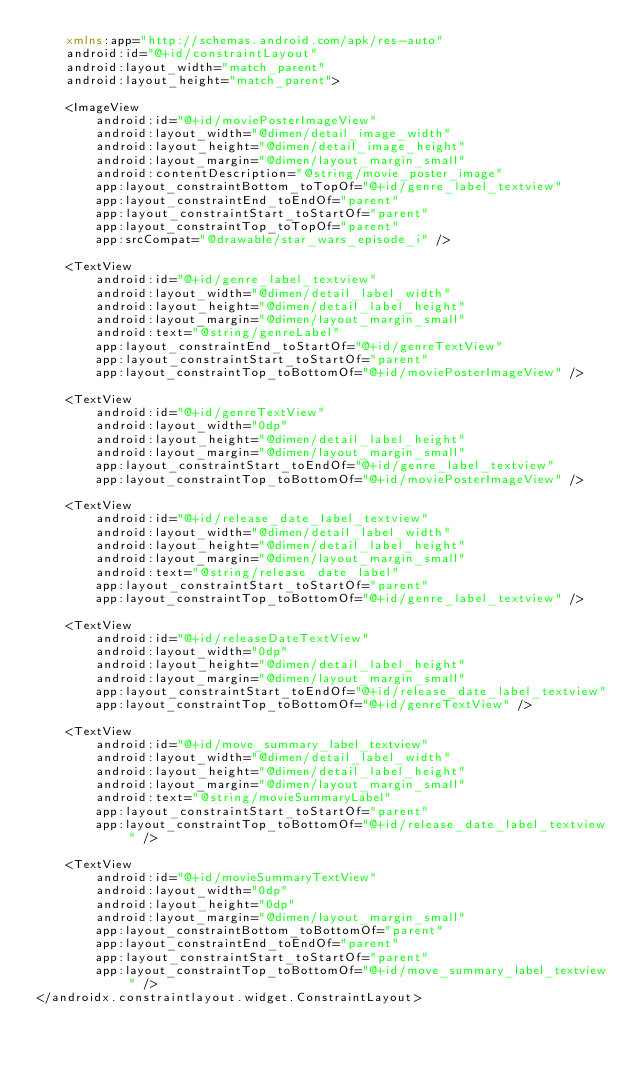Convert code to text. <code><loc_0><loc_0><loc_500><loc_500><_XML_>    xmlns:app="http://schemas.android.com/apk/res-auto"
    android:id="@+id/constraintLayout"
    android:layout_width="match_parent"
    android:layout_height="match_parent">

    <ImageView
        android:id="@+id/moviePosterImageView"
        android:layout_width="@dimen/detail_image_width"
        android:layout_height="@dimen/detail_image_height"
        android:layout_margin="@dimen/layout_margin_small"
        android:contentDescription="@string/movie_poster_image"
        app:layout_constraintBottom_toTopOf="@+id/genre_label_textview"
        app:layout_constraintEnd_toEndOf="parent"
        app:layout_constraintStart_toStartOf="parent"
        app:layout_constraintTop_toTopOf="parent"
        app:srcCompat="@drawable/star_wars_episode_i" />

    <TextView
        android:id="@+id/genre_label_textview"
        android:layout_width="@dimen/detail_label_width"
        android:layout_height="@dimen/detail_label_height"
        android:layout_margin="@dimen/layout_margin_small"
        android:text="@string/genreLabel"
        app:layout_constraintEnd_toStartOf="@+id/genreTextView"
        app:layout_constraintStart_toStartOf="parent"
        app:layout_constraintTop_toBottomOf="@+id/moviePosterImageView" />

    <TextView
        android:id="@+id/genreTextView"
        android:layout_width="0dp"
        android:layout_height="@dimen/detail_label_height"
        android:layout_margin="@dimen/layout_margin_small"
        app:layout_constraintStart_toEndOf="@+id/genre_label_textview"
        app:layout_constraintTop_toBottomOf="@+id/moviePosterImageView" />

    <TextView
        android:id="@+id/release_date_label_textview"
        android:layout_width="@dimen/detail_label_width"
        android:layout_height="@dimen/detail_label_height"
        android:layout_margin="@dimen/layout_margin_small"
        android:text="@string/release_date_label"
        app:layout_constraintStart_toStartOf="parent"
        app:layout_constraintTop_toBottomOf="@+id/genre_label_textview" />

    <TextView
        android:id="@+id/releaseDateTextView"
        android:layout_width="0dp"
        android:layout_height="@dimen/detail_label_height"
        android:layout_margin="@dimen/layout_margin_small"
        app:layout_constraintStart_toEndOf="@+id/release_date_label_textview"
        app:layout_constraintTop_toBottomOf="@+id/genreTextView" />

    <TextView
        android:id="@+id/move_summary_label_textview"
        android:layout_width="@dimen/detail_label_width"
        android:layout_height="@dimen/detail_label_height"
        android:layout_margin="@dimen/layout_margin_small"
        android:text="@string/movieSummaryLabel"
        app:layout_constraintStart_toStartOf="parent"
        app:layout_constraintTop_toBottomOf="@+id/release_date_label_textview" />

    <TextView
        android:id="@+id/movieSummaryTextView"
        android:layout_width="0dp"
        android:layout_height="0dp"
        android:layout_margin="@dimen/layout_margin_small"
        app:layout_constraintBottom_toBottomOf="parent"
        app:layout_constraintEnd_toEndOf="parent"
        app:layout_constraintStart_toStartOf="parent"
        app:layout_constraintTop_toBottomOf="@+id/move_summary_label_textview" />
</androidx.constraintlayout.widget.ConstraintLayout></code> 